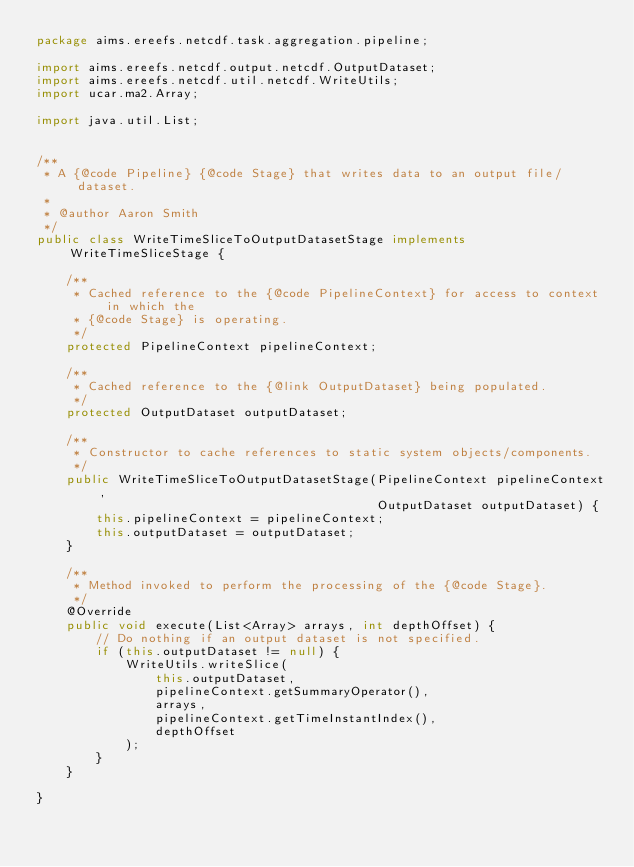<code> <loc_0><loc_0><loc_500><loc_500><_Java_>package aims.ereefs.netcdf.task.aggregation.pipeline;

import aims.ereefs.netcdf.output.netcdf.OutputDataset;
import aims.ereefs.netcdf.util.netcdf.WriteUtils;
import ucar.ma2.Array;

import java.util.List;


/**
 * A {@code Pipeline} {@code Stage} that writes data to an output file/dataset.
 *
 * @author Aaron Smith
 */
public class WriteTimeSliceToOutputDatasetStage implements WriteTimeSliceStage {

    /**
     * Cached reference to the {@code PipelineContext} for access to context in which the
     * {@code Stage} is operating.
     */
    protected PipelineContext pipelineContext;

    /**
     * Cached reference to the {@link OutputDataset} being populated.
     */
    protected OutputDataset outputDataset;

    /**
     * Constructor to cache references to static system objects/components.
     */
    public WriteTimeSliceToOutputDatasetStage(PipelineContext pipelineContext,
                                              OutputDataset outputDataset) {
        this.pipelineContext = pipelineContext;
        this.outputDataset = outputDataset;
    }

    /**
     * Method invoked to perform the processing of the {@code Stage}.
     */
    @Override
    public void execute(List<Array> arrays, int depthOffset) {
        // Do nothing if an output dataset is not specified.
        if (this.outputDataset != null) {
            WriteUtils.writeSlice(
                this.outputDataset,
                pipelineContext.getSummaryOperator(),
                arrays,
                pipelineContext.getTimeInstantIndex(),
                depthOffset
            );
        }
    }

}
</code> 